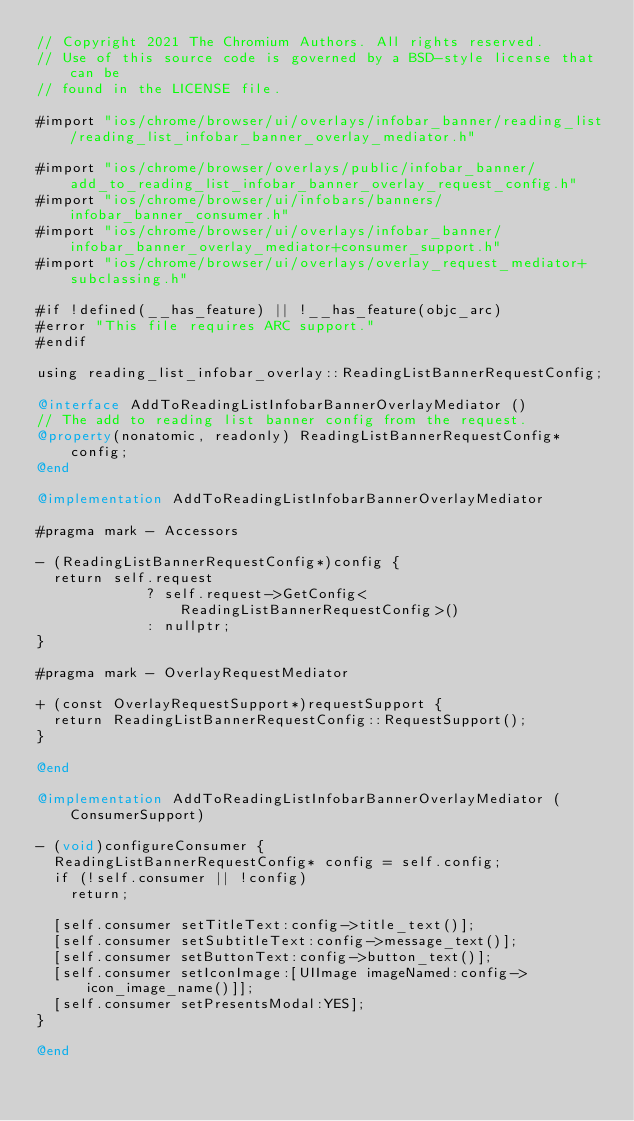Convert code to text. <code><loc_0><loc_0><loc_500><loc_500><_ObjectiveC_>// Copyright 2021 The Chromium Authors. All rights reserved.
// Use of this source code is governed by a BSD-style license that can be
// found in the LICENSE file.

#import "ios/chrome/browser/ui/overlays/infobar_banner/reading_list/reading_list_infobar_banner_overlay_mediator.h"

#import "ios/chrome/browser/overlays/public/infobar_banner/add_to_reading_list_infobar_banner_overlay_request_config.h"
#import "ios/chrome/browser/ui/infobars/banners/infobar_banner_consumer.h"
#import "ios/chrome/browser/ui/overlays/infobar_banner/infobar_banner_overlay_mediator+consumer_support.h"
#import "ios/chrome/browser/ui/overlays/overlay_request_mediator+subclassing.h"

#if !defined(__has_feature) || !__has_feature(objc_arc)
#error "This file requires ARC support."
#endif

using reading_list_infobar_overlay::ReadingListBannerRequestConfig;

@interface AddToReadingListInfobarBannerOverlayMediator ()
// The add to reading list banner config from the request.
@property(nonatomic, readonly) ReadingListBannerRequestConfig* config;
@end

@implementation AddToReadingListInfobarBannerOverlayMediator

#pragma mark - Accessors

- (ReadingListBannerRequestConfig*)config {
  return self.request
             ? self.request->GetConfig<ReadingListBannerRequestConfig>()
             : nullptr;
}

#pragma mark - OverlayRequestMediator

+ (const OverlayRequestSupport*)requestSupport {
  return ReadingListBannerRequestConfig::RequestSupport();
}

@end

@implementation AddToReadingListInfobarBannerOverlayMediator (ConsumerSupport)

- (void)configureConsumer {
  ReadingListBannerRequestConfig* config = self.config;
  if (!self.consumer || !config)
    return;

  [self.consumer setTitleText:config->title_text()];
  [self.consumer setSubtitleText:config->message_text()];
  [self.consumer setButtonText:config->button_text()];
  [self.consumer setIconImage:[UIImage imageNamed:config->icon_image_name()]];
  [self.consumer setPresentsModal:YES];
}

@end
</code> 